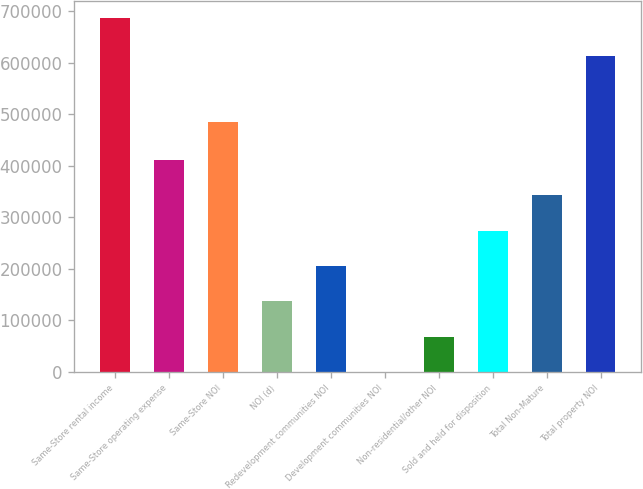<chart> <loc_0><loc_0><loc_500><loc_500><bar_chart><fcel>Same-Store rental income<fcel>Same-Store operating expense<fcel>Same-Store NOI<fcel>NOI (d)<fcel>Redevelopment communities NOI<fcel>Development communities NOI<fcel>Non-residential/other NOI<fcel>Sold and held for disposition<fcel>Total Non-Mature<fcel>Total property NOI<nl><fcel>686589<fcel>411999<fcel>486116<fcel>137409<fcel>206056<fcel>114<fcel>68761.5<fcel>274704<fcel>343352<fcel>613869<nl></chart> 